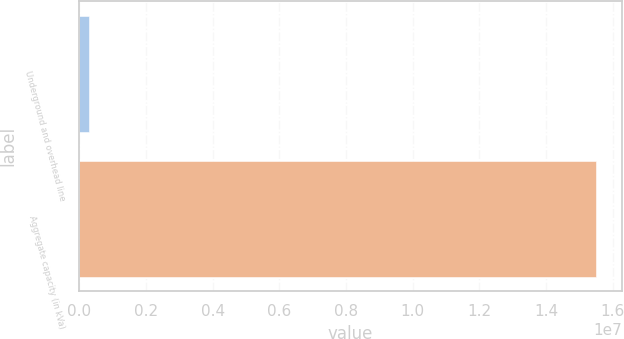Convert chart to OTSL. <chart><loc_0><loc_0><loc_500><loc_500><bar_chart><fcel>Underground and overhead line<fcel>Aggregate capacity (in kVa)<nl><fcel>289174<fcel>1.54961e+07<nl></chart> 